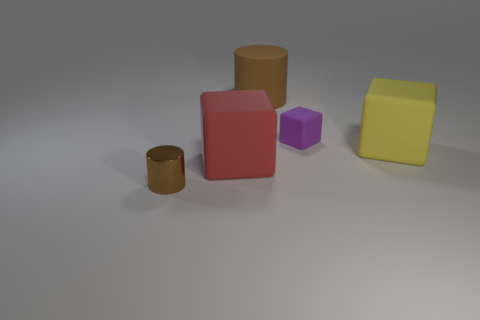Add 1 big yellow rubber cubes. How many objects exist? 6 Subtract all cylinders. How many objects are left? 3 Add 4 big gray shiny spheres. How many big gray shiny spheres exist? 4 Subtract 0 cyan cubes. How many objects are left? 5 Subtract all tiny purple things. Subtract all tiny things. How many objects are left? 2 Add 3 small brown things. How many small brown things are left? 4 